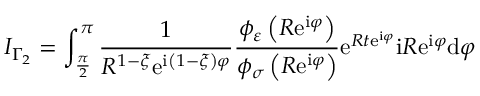<formula> <loc_0><loc_0><loc_500><loc_500>I _ { \Gamma _ { 2 } } = \int _ { \frac { \pi } { 2 } } ^ { \pi } \frac { 1 } { R ^ { 1 - \xi } e ^ { i \left ( 1 - \xi \right ) \varphi } } \frac { \phi _ { \varepsilon } \left ( R e ^ { i \varphi } \right ) } { \phi _ { \sigma } \left ( R e ^ { i \varphi } \right ) } e ^ { R t e ^ { i \varphi } } i R e ^ { i \varphi } d \varphi</formula> 